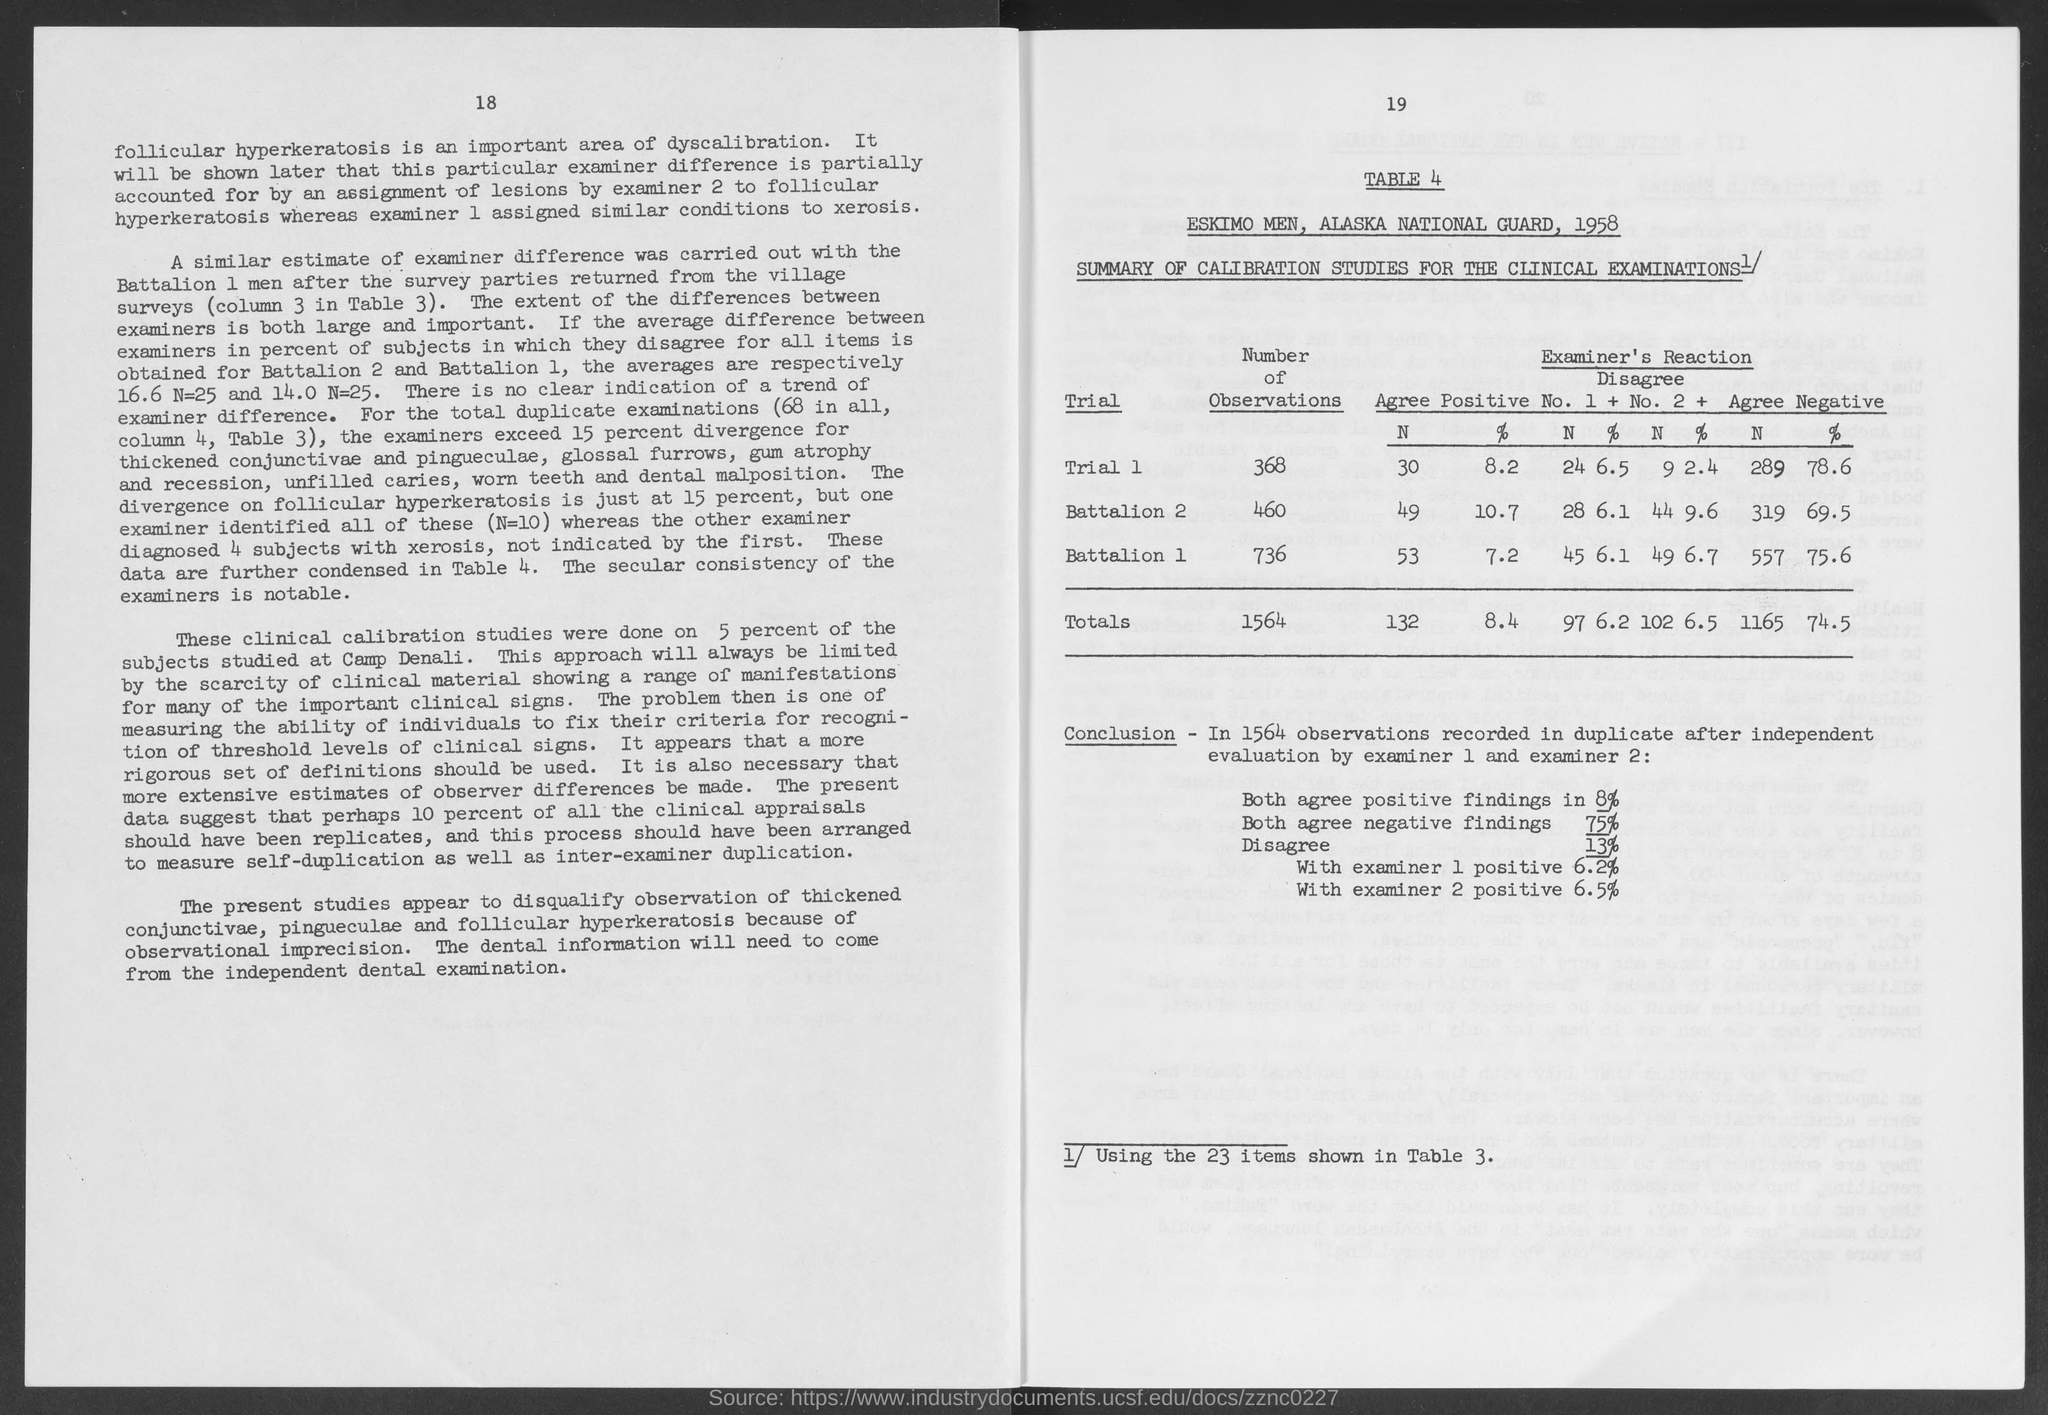Draw attention to some important aspects in this diagram. There are 736 observations in Battalion 1. In trial 1, there were 368 observations. In total, there were 1564 observations. There are 460 observations in Battalion 2. Please provide the table number, starting with 4. 